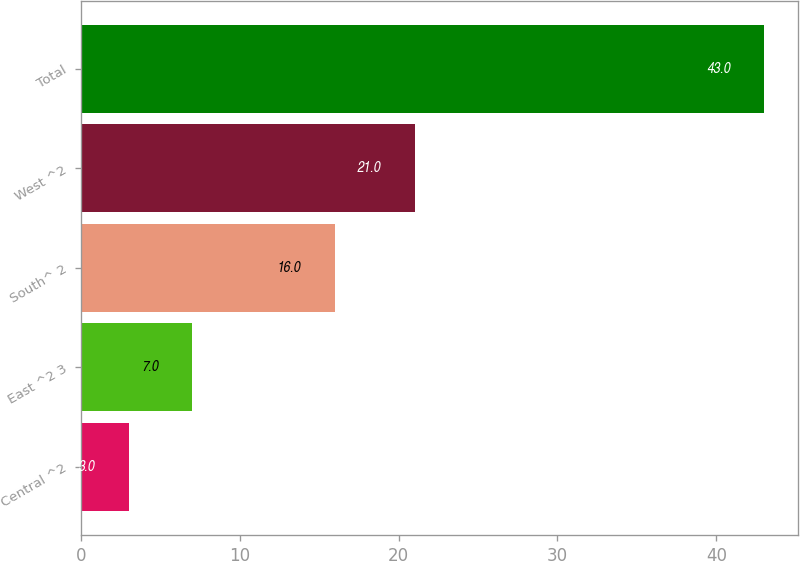Convert chart to OTSL. <chart><loc_0><loc_0><loc_500><loc_500><bar_chart><fcel>Central ^2<fcel>East ^2 3<fcel>South^ 2<fcel>West ^2<fcel>Total<nl><fcel>3<fcel>7<fcel>16<fcel>21<fcel>43<nl></chart> 